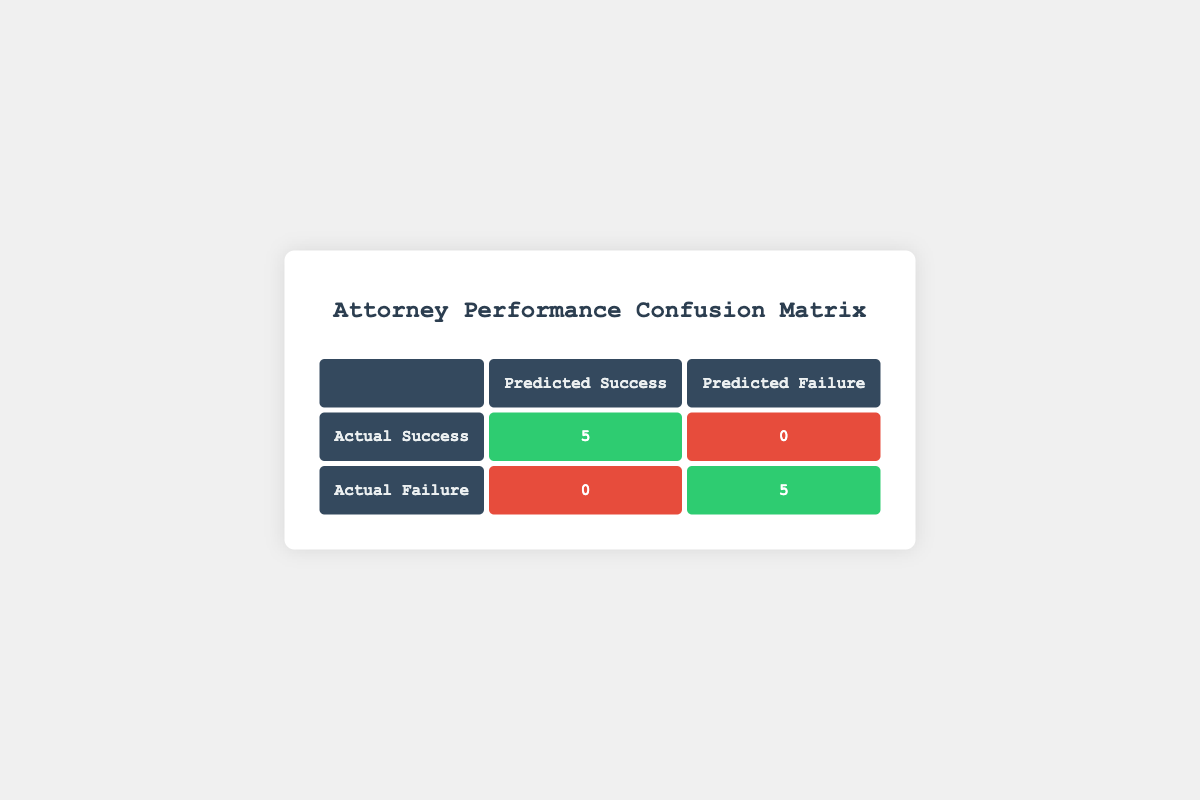What is the count of successful evaluations? From the table, the count of successful evaluations is found in the cell labeled "Actual Success" under "Predicted Success," which has a value of 5.
Answer: 5 How many attorneys had successful outcomes with strong closing arguments? The "True Positive" count indicates how many attorneys had both successful evaluations and strong closing arguments, which is 5 from the table.
Answer: 5 Did any attorneys achieve a successful outcome with weak closing arguments? The table indicates that there were no instances where attorneys received a successful outcome while having weak closing arguments, as shown in the "False Negative" count, which is 0.
Answer: No What is the total number of unsuccessful evaluations? To find the total number of unsuccessful evaluations, we can look at the "Actual Failure" row and sum the values under both predicted outcomes: 0 (Predicted Success) + 5 (Predicted Failure) = 5.
Answer: 5 Is it true that all attorneys with strong closing arguments succeeded? Yes, referencing the "True Positive" count, it confirms that every attorney with strong closing arguments successfully achieved a positive evaluation, totaling 5.
Answer: Yes How many total combinations of successful and unsuccessful evaluations are there in the table? The total combinations can be calculated by adding all values in the matrix. Here, 5 (True Positive) + 0 (False Negative) + 0 (False Positive) + 5 (True Negative) = 10 total combinations.
Answer: 10 What percentage of attorneys with weak closing arguments were successful? Looking at the "Weak" rows, we see that 0 attorneys were successful out of 5 total evaluated, which means the percentage is (0/5) * 100 = 0%.
Answer: 0% How many attorneys with strong arguments failed their evaluations? The table provides the count labeled as "False Positive," which indicates the number of attorneys who had strong arguments but received unsuccessful evaluations. This count is 0.
Answer: 0 